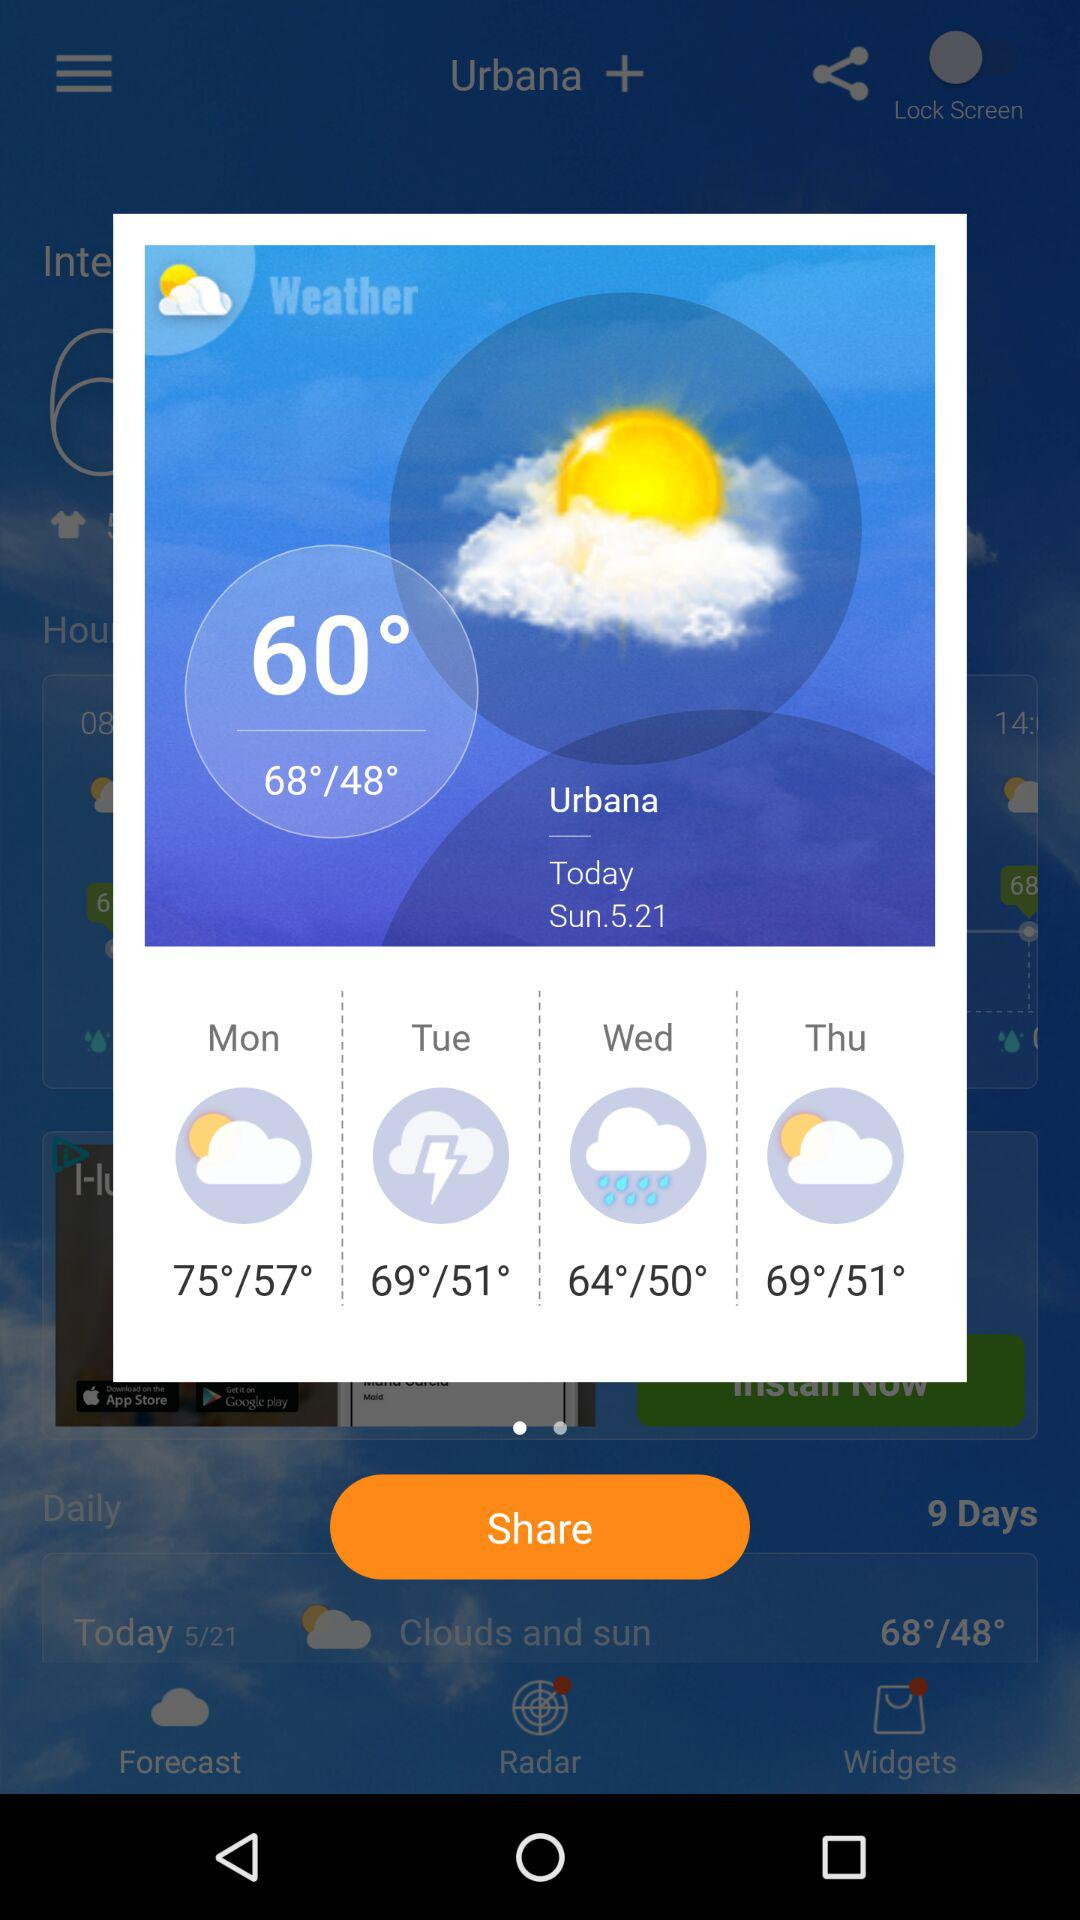What will be the highest temperature on Wednesday? The highest temperature will be 64°. 